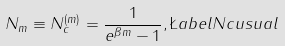<formula> <loc_0><loc_0><loc_500><loc_500>N _ { m } \equiv N _ { c } ^ { ( m ) } = \frac { 1 } { e ^ { \beta m } - 1 } , \L a b e l { N c u s u a l }</formula> 